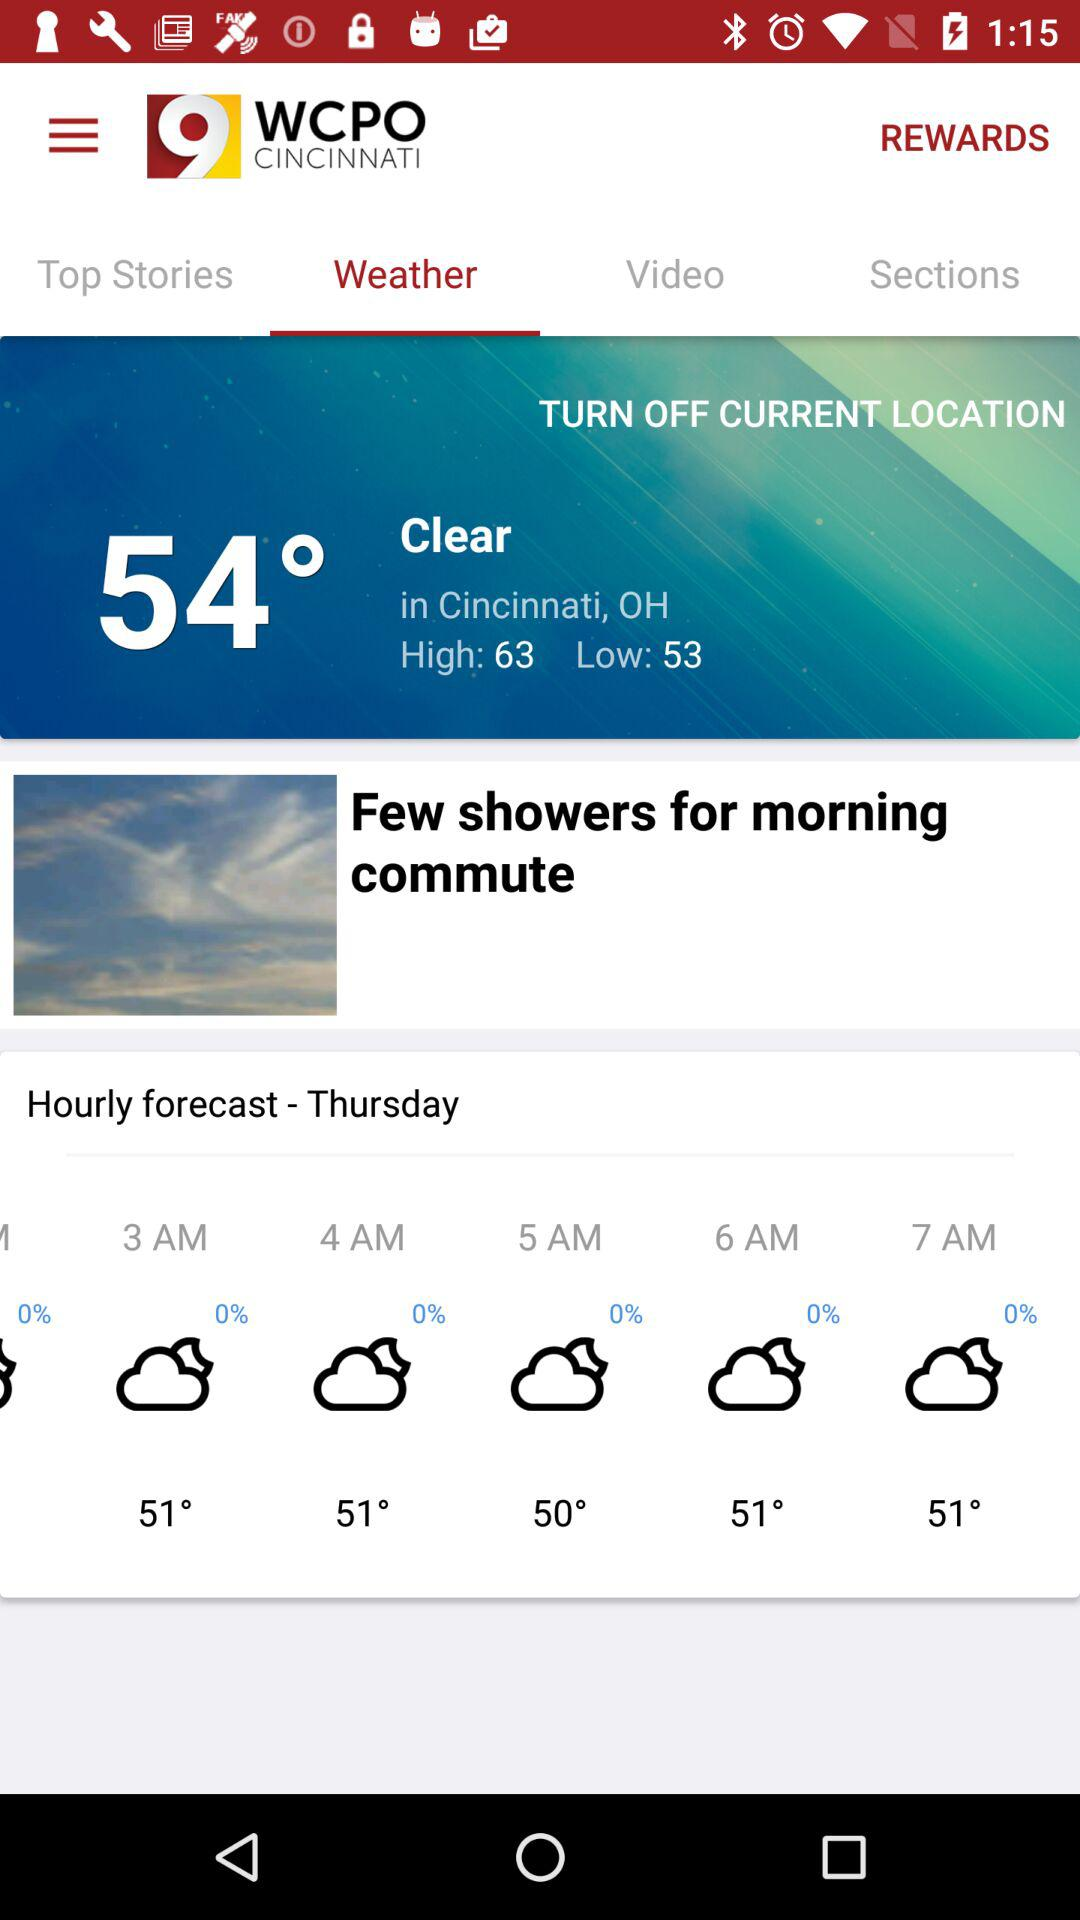What's the weather condition in Cincinnati,OH? The weather condition is "Clear". 